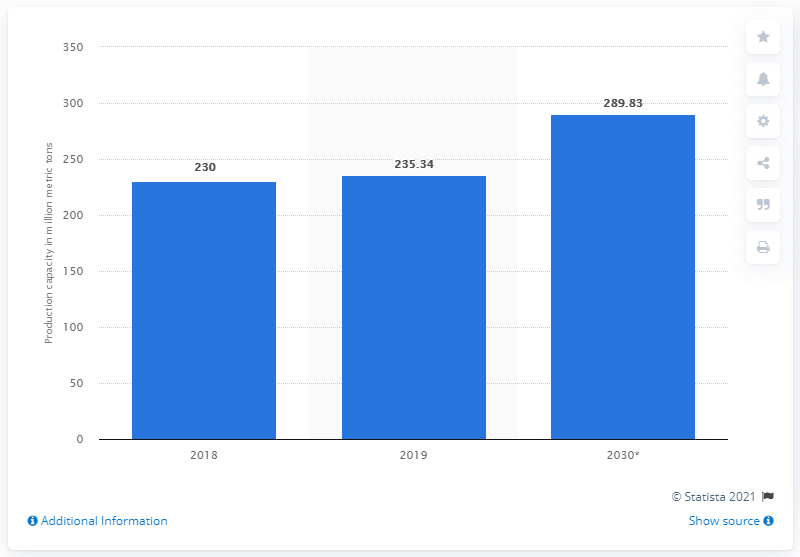Give some essential details in this illustration. In 2019, the global production capacity of ammonia was 235.34 million metric tons. The global production capacity of ammonia is expected to reach 289.83 gigatons by 2030. 